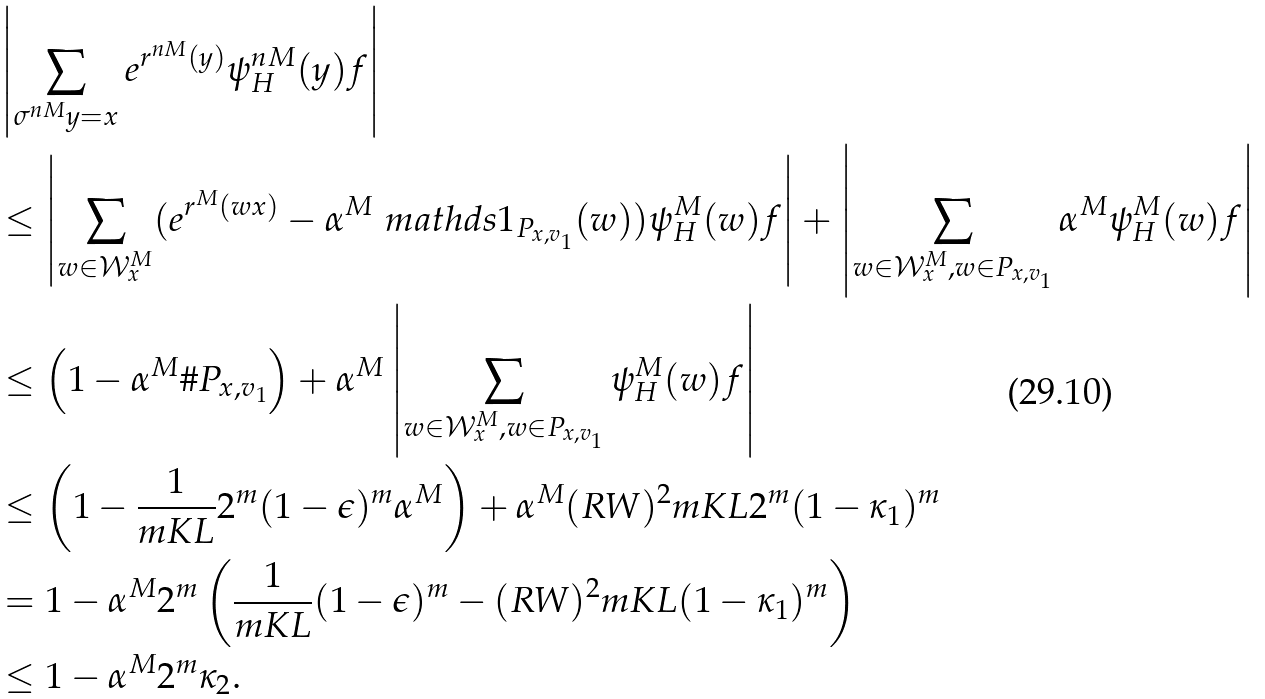Convert formula to latex. <formula><loc_0><loc_0><loc_500><loc_500>& \left | \sum _ { \sigma ^ { n M } y = x } e ^ { r ^ { n M } ( y ) } \psi _ { H } ^ { n M } ( y ) f \right | \\ & \leq \left | \sum _ { w \in \mathcal { W } ^ { M } _ { x } } ( e ^ { r ^ { M } ( w x ) } - \alpha ^ { M } \ m a t h d s { 1 } _ { P _ { x , v _ { 1 } } } ( w ) ) \psi _ { H } ^ { M } ( w ) f \right | + \left | \sum _ { w \in \mathcal { W } ^ { M } _ { x } , w \in P _ { x , v _ { 1 } } } \alpha ^ { M } \psi _ { H } ^ { M } ( w ) f \right | \\ & \leq \left ( 1 - \alpha ^ { M } \# P _ { x , v _ { 1 } } \right ) + \alpha ^ { M } \left | \sum _ { w \in \mathcal { W } ^ { M } _ { x } , w \in P _ { x , v _ { 1 } } } \psi _ { H } ^ { M } ( w ) f \right | \\ & \leq \left ( 1 - \frac { 1 } { m K L } 2 ^ { m } ( 1 - \epsilon ) ^ { m } \alpha ^ { M } \right ) + \alpha ^ { M } ( R W ) ^ { 2 } m K L 2 ^ { m } ( 1 - \kappa _ { 1 } ) ^ { m } \\ & = 1 - \alpha ^ { M } 2 ^ { m } \left ( \frac { 1 } { m K L } ( 1 - \epsilon ) ^ { m } - ( R W ) ^ { 2 } m K L ( 1 - \kappa _ { 1 } ) ^ { m } \right ) \\ & \leq 1 - \alpha ^ { M } 2 ^ { m } \kappa _ { 2 } .</formula> 